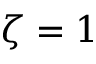<formula> <loc_0><loc_0><loc_500><loc_500>\zeta = 1</formula> 